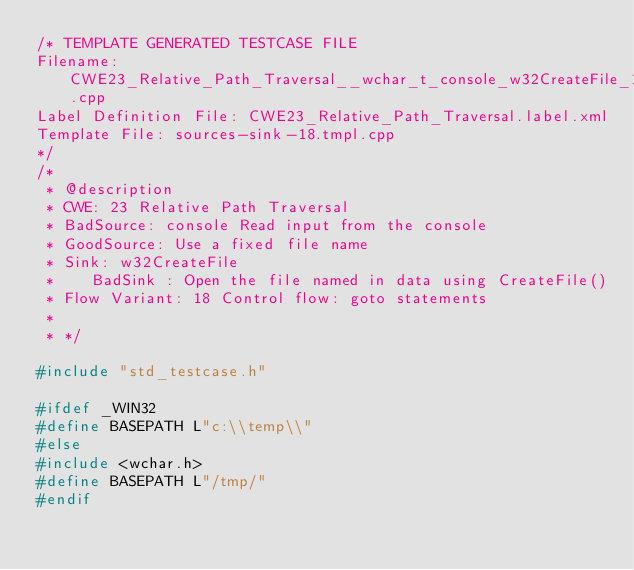<code> <loc_0><loc_0><loc_500><loc_500><_C++_>/* TEMPLATE GENERATED TESTCASE FILE
Filename: CWE23_Relative_Path_Traversal__wchar_t_console_w32CreateFile_18.cpp
Label Definition File: CWE23_Relative_Path_Traversal.label.xml
Template File: sources-sink-18.tmpl.cpp
*/
/*
 * @description
 * CWE: 23 Relative Path Traversal
 * BadSource: console Read input from the console
 * GoodSource: Use a fixed file name
 * Sink: w32CreateFile
 *    BadSink : Open the file named in data using CreateFile()
 * Flow Variant: 18 Control flow: goto statements
 *
 * */

#include "std_testcase.h"

#ifdef _WIN32
#define BASEPATH L"c:\\temp\\"
#else
#include <wchar.h>
#define BASEPATH L"/tmp/"
#endif
</code> 